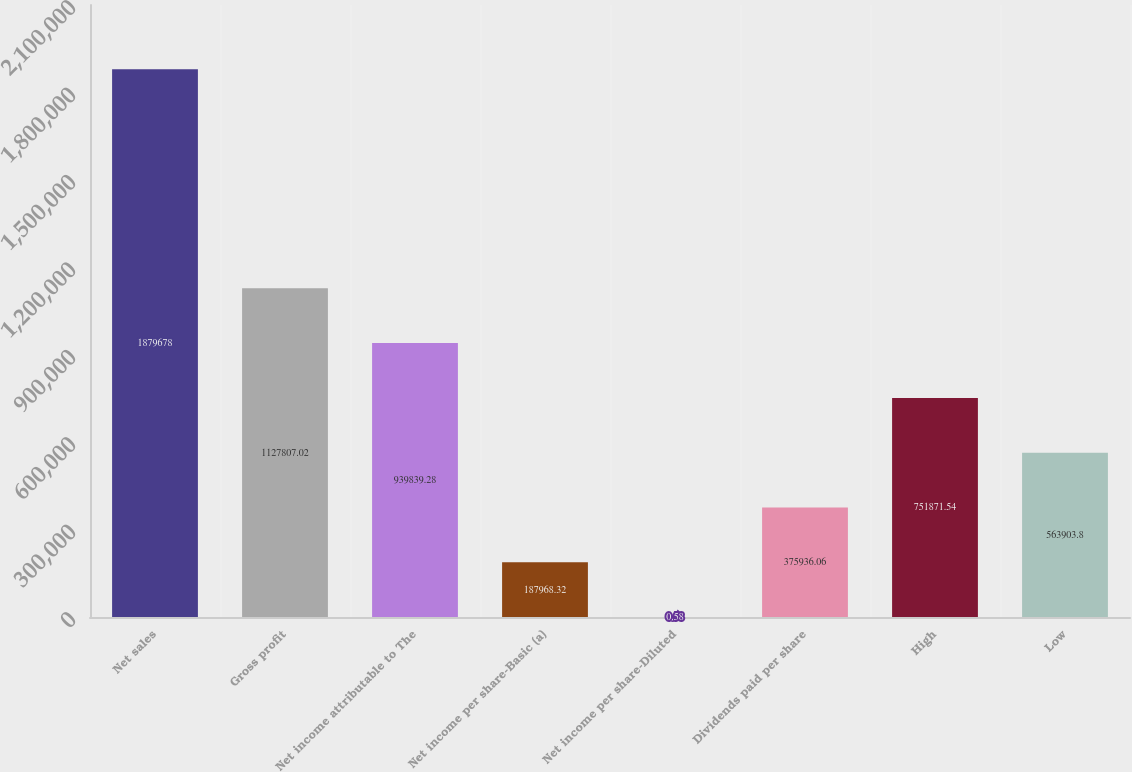Convert chart to OTSL. <chart><loc_0><loc_0><loc_500><loc_500><bar_chart><fcel>Net sales<fcel>Gross profit<fcel>Net income attributable to The<fcel>Net income per share-Basic (a)<fcel>Net income per share-Diluted<fcel>Dividends paid per share<fcel>High<fcel>Low<nl><fcel>1.87968e+06<fcel>1.12781e+06<fcel>939839<fcel>187968<fcel>0.58<fcel>375936<fcel>751872<fcel>563904<nl></chart> 